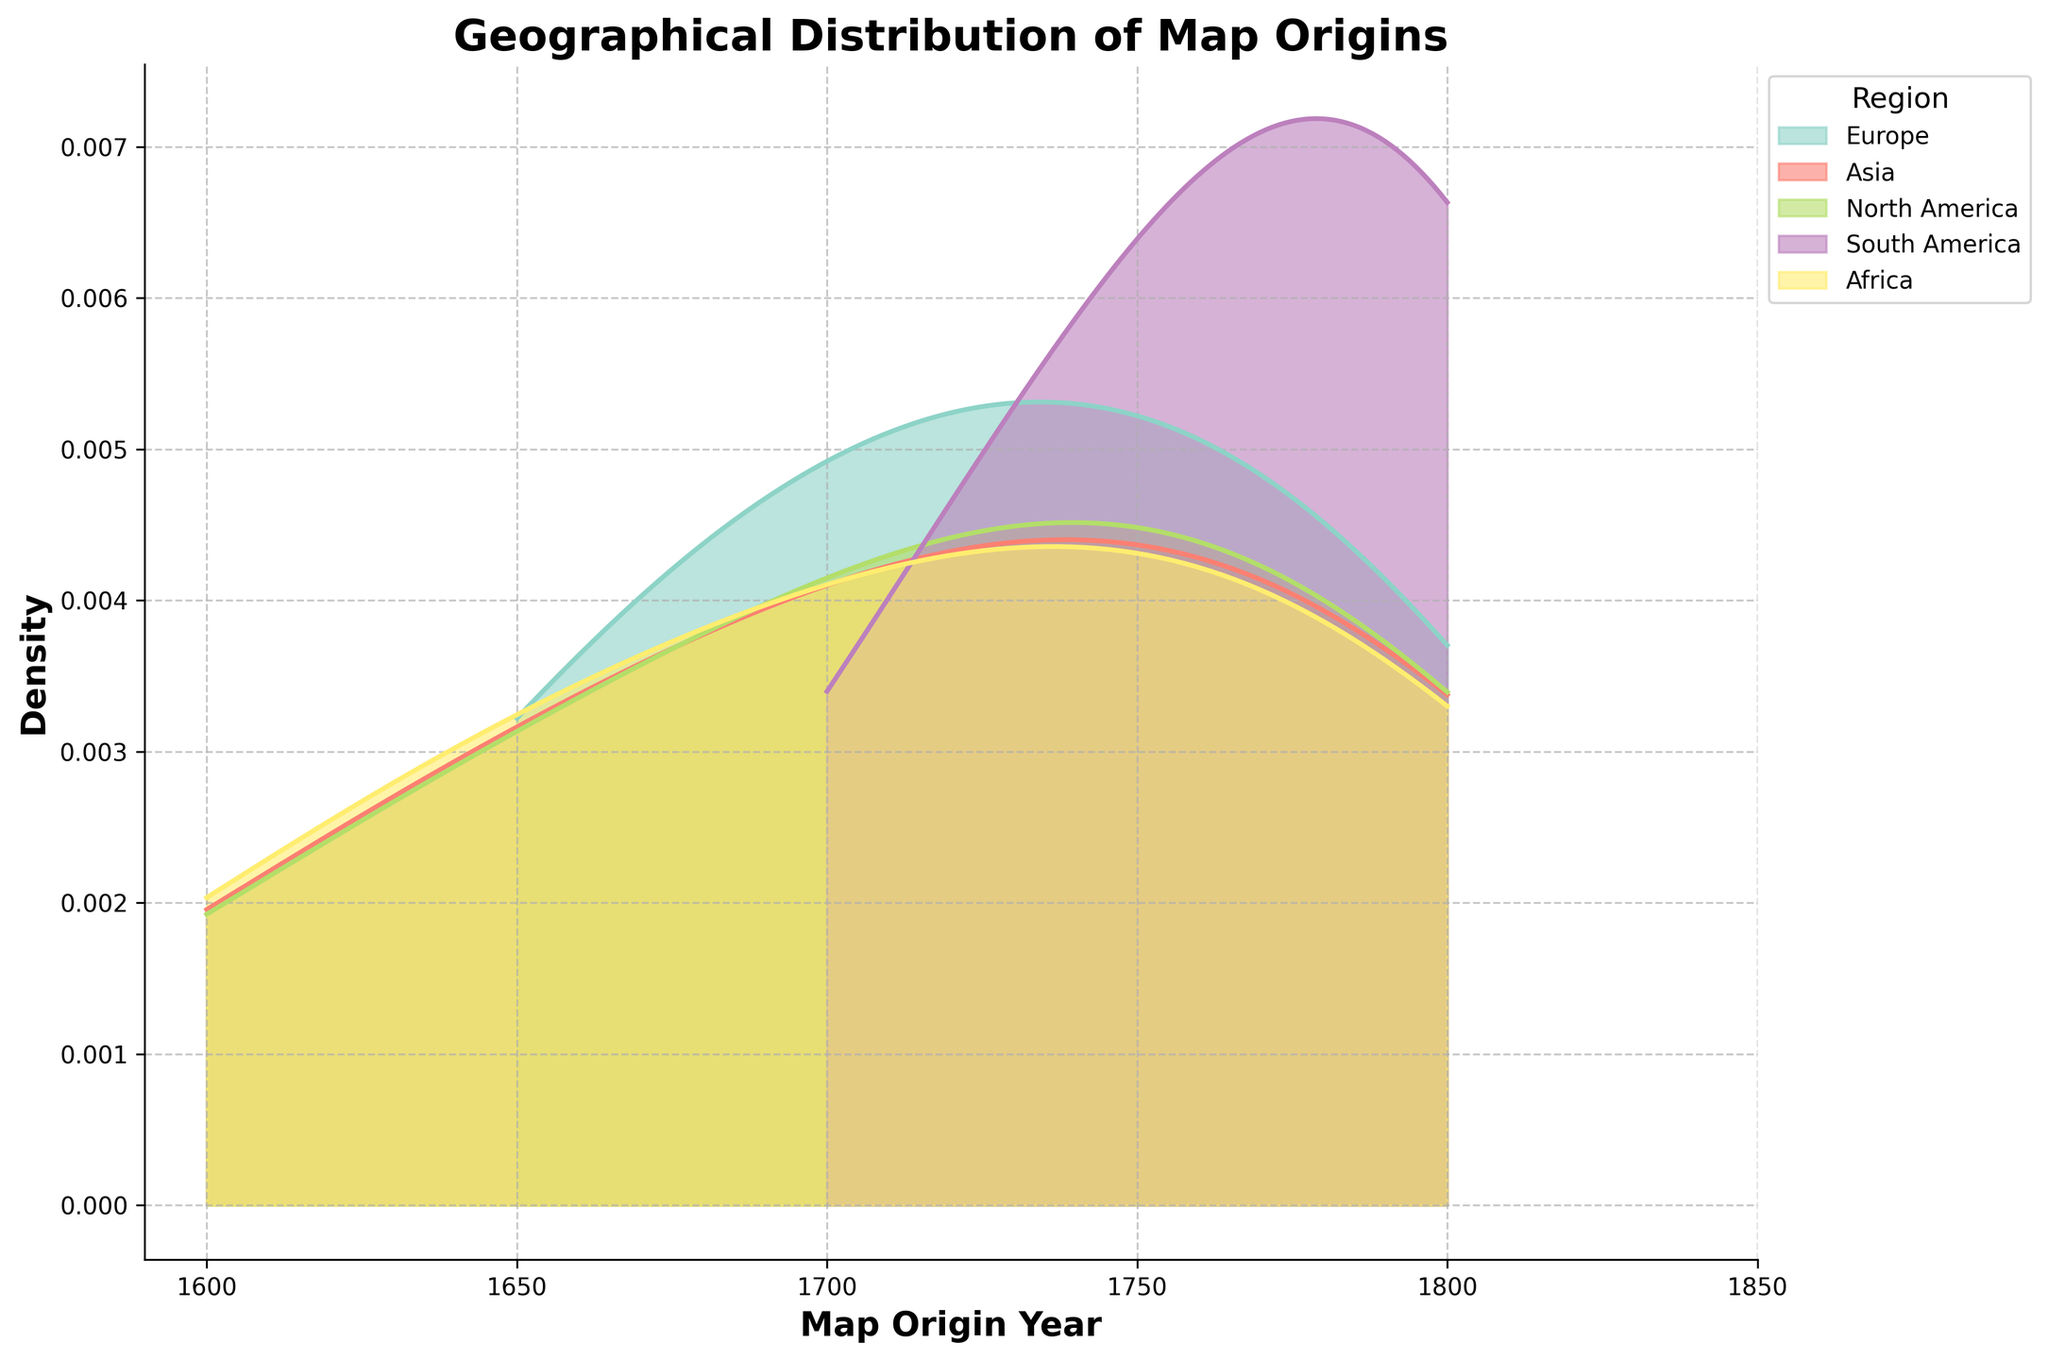What is the title of the figure? The title of the figure can be found at the top of the plot area. It typically gives an indication of what the plot is about.
Answer: Geographical Distribution of Map Origins Which region has the highest density around the year 1750? To determine the highest density, look at the peaked area of the density plot around the year 1750. Identify the region corresponding to that peak.
Answer: Asia What is the range of years displayed on the x-axis? The x-axis typically shows the range of years included in the data. Check the x-axis from the start to the end.
Answer: 1600 to 1800 Which regions show density values after the year 1700? Look for the colored density bands that extend beyond the year 1700 on the x-axis. Identify the regions each color represents.
Answer: Europe, Asia, North America, South America, Africa In which year does Europe show its highest density? Find the peak point of the density curve for Europe. The x-coordinate of this peak point represents the year with the highest density.
Answer: 1750 Compare the density distribution between Europe and North America. Which region shows higher density throughout the range? Compare the height and spread of Europe’s density curve with that of North America across the entire x-axis range. The region with the generally higher curve has a higher density.
Answer: Europe What is the color associated with Asia on the plot? The color of the density curve for Asia can be determined by locating the legend and identifying the color corresponding to Asia.
Answer: Green (or specific color set by the palette used) How does the density for South America change from 1700 to 1800? Observe the density curve corresponding to South America from 1700 to 1800. Notice the changes in the height and spread of the curve.
Answer: Increases Which region has the broadest density distribution? Compare the width of the density curves for all regions. The region with the widest curve has the broadest density distribution.
Answer: Africa 